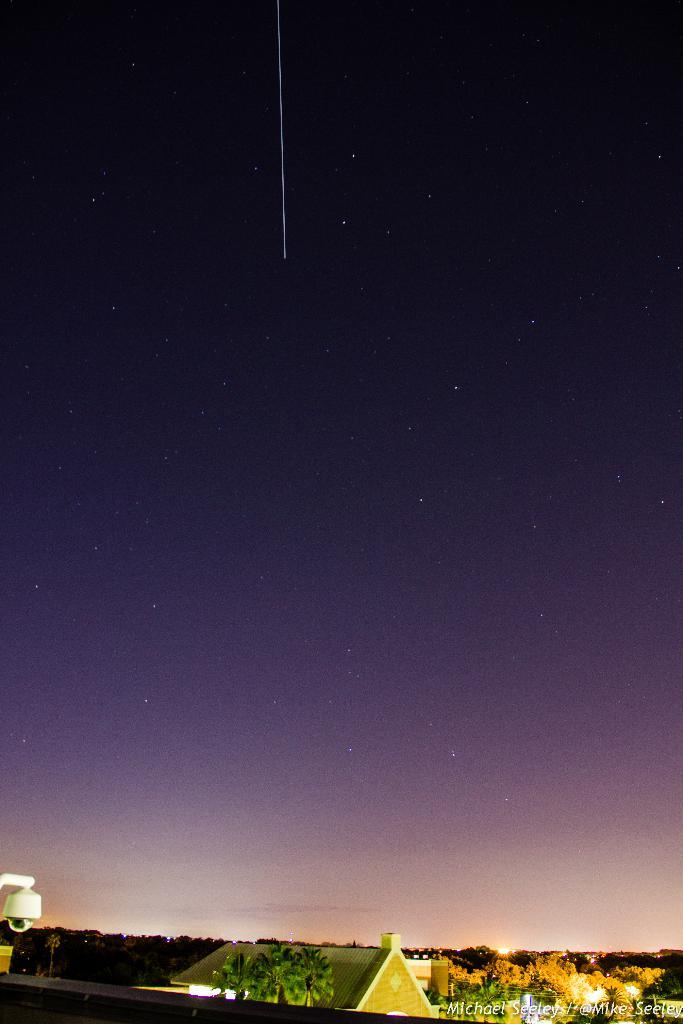What type of structures can be seen in the image? There are houses in the image. What other natural elements are present in the image? There are trees in the image. Where is the streetlight located in the image? The streetlight is on the left side of the image. What additional feature can be found on the right side of the image? There is a watermark on the right side of the image. What time of day does the image depict, and can you see the nose of the person walking down the street? The time of day is not mentioned in the image, and there is no person walking down the street with a visible nose. 